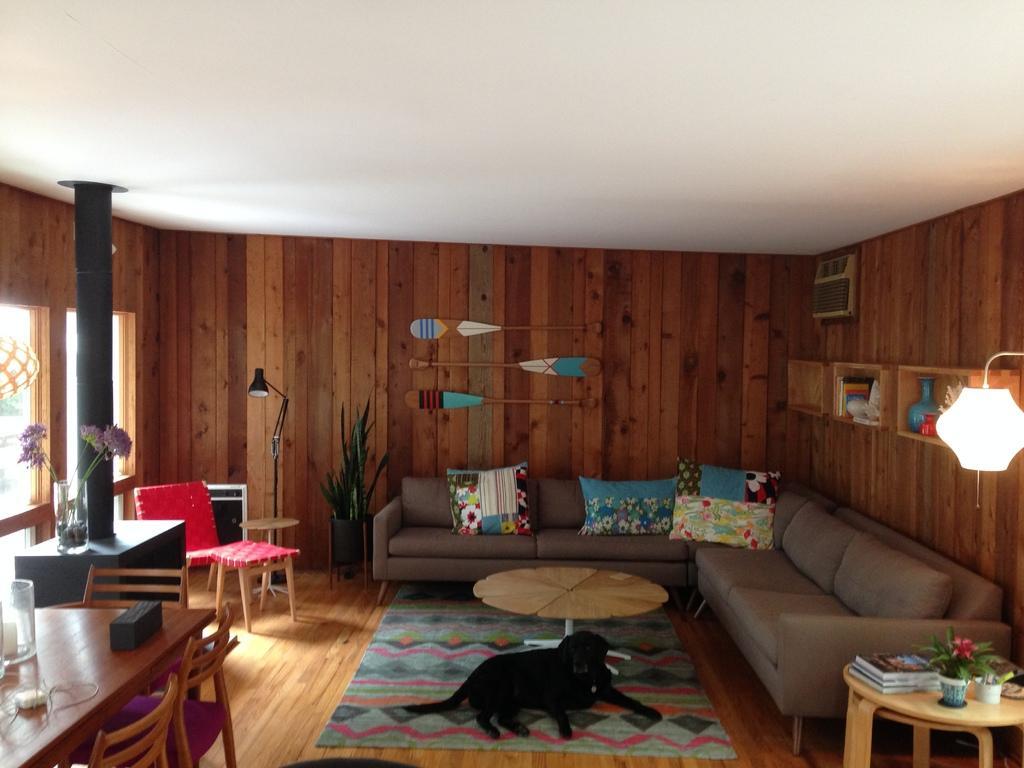How would you summarize this image in a sentence or two? In this image I can see sofas and few cushions on it. I can also see tables, few chairs, a dog, a lamp, a plant and few books on this table. 